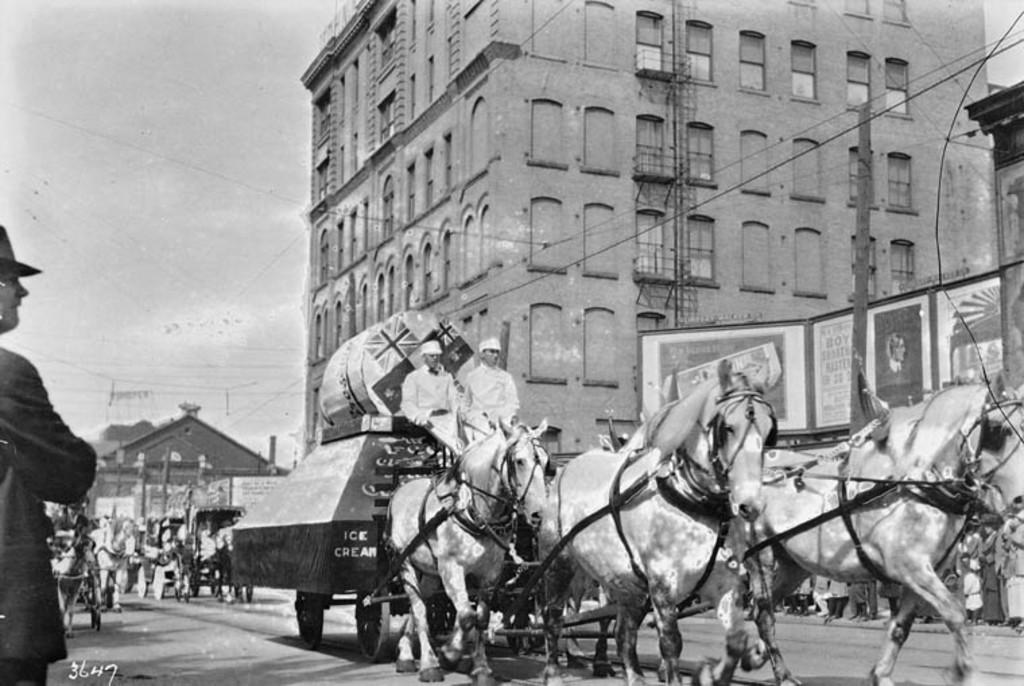What can be seen in the background of the image? There is a sky in the image. What type of structures are present in the image? There are buildings in the image. Who or what else is present in the image? There are people and horses in the image. What type of bait is being used to attract the horses in the image? There is no bait present in the image, as the horses are not being attracted to anything. 